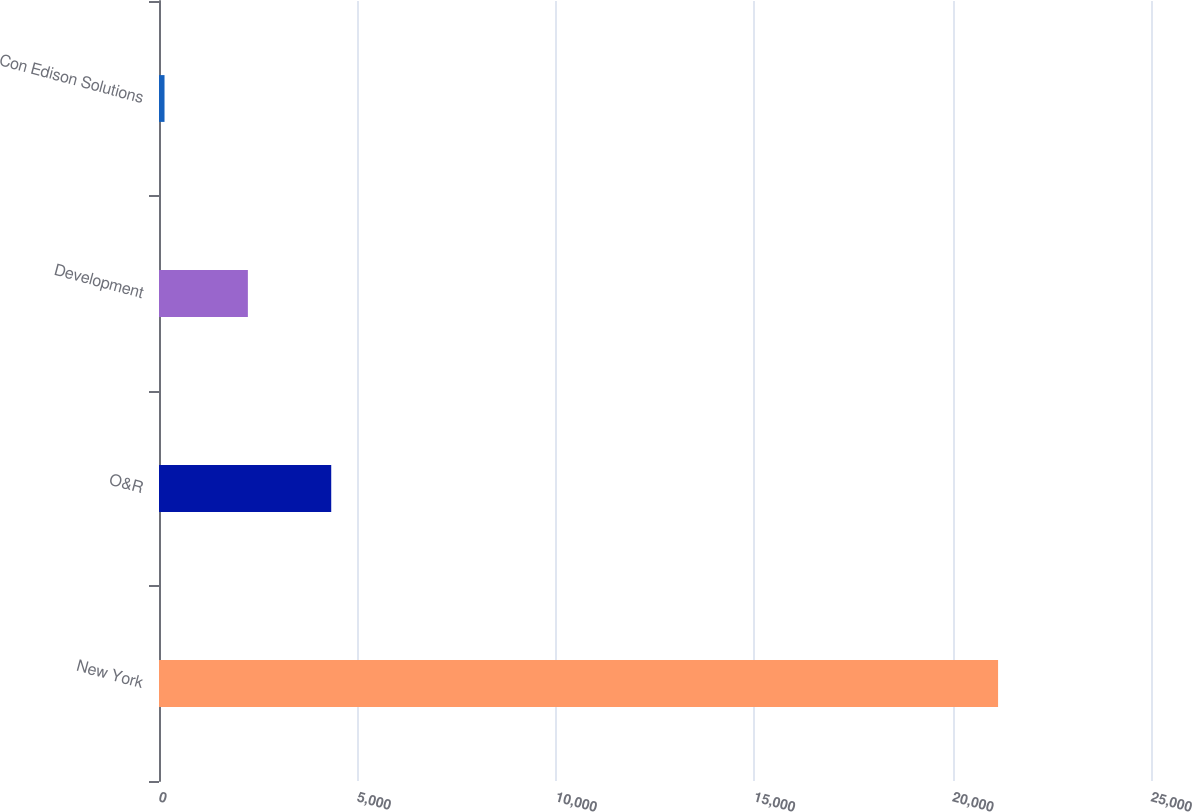<chart> <loc_0><loc_0><loc_500><loc_500><bar_chart><fcel>New York<fcel>O&R<fcel>Development<fcel>Con Edison Solutions<nl><fcel>21146<fcel>4340.4<fcel>2239.7<fcel>139<nl></chart> 